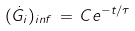Convert formula to latex. <formula><loc_0><loc_0><loc_500><loc_500>( \dot { G } _ { i } ) _ { i n f } \, = \, C e ^ { - t / \tau }</formula> 